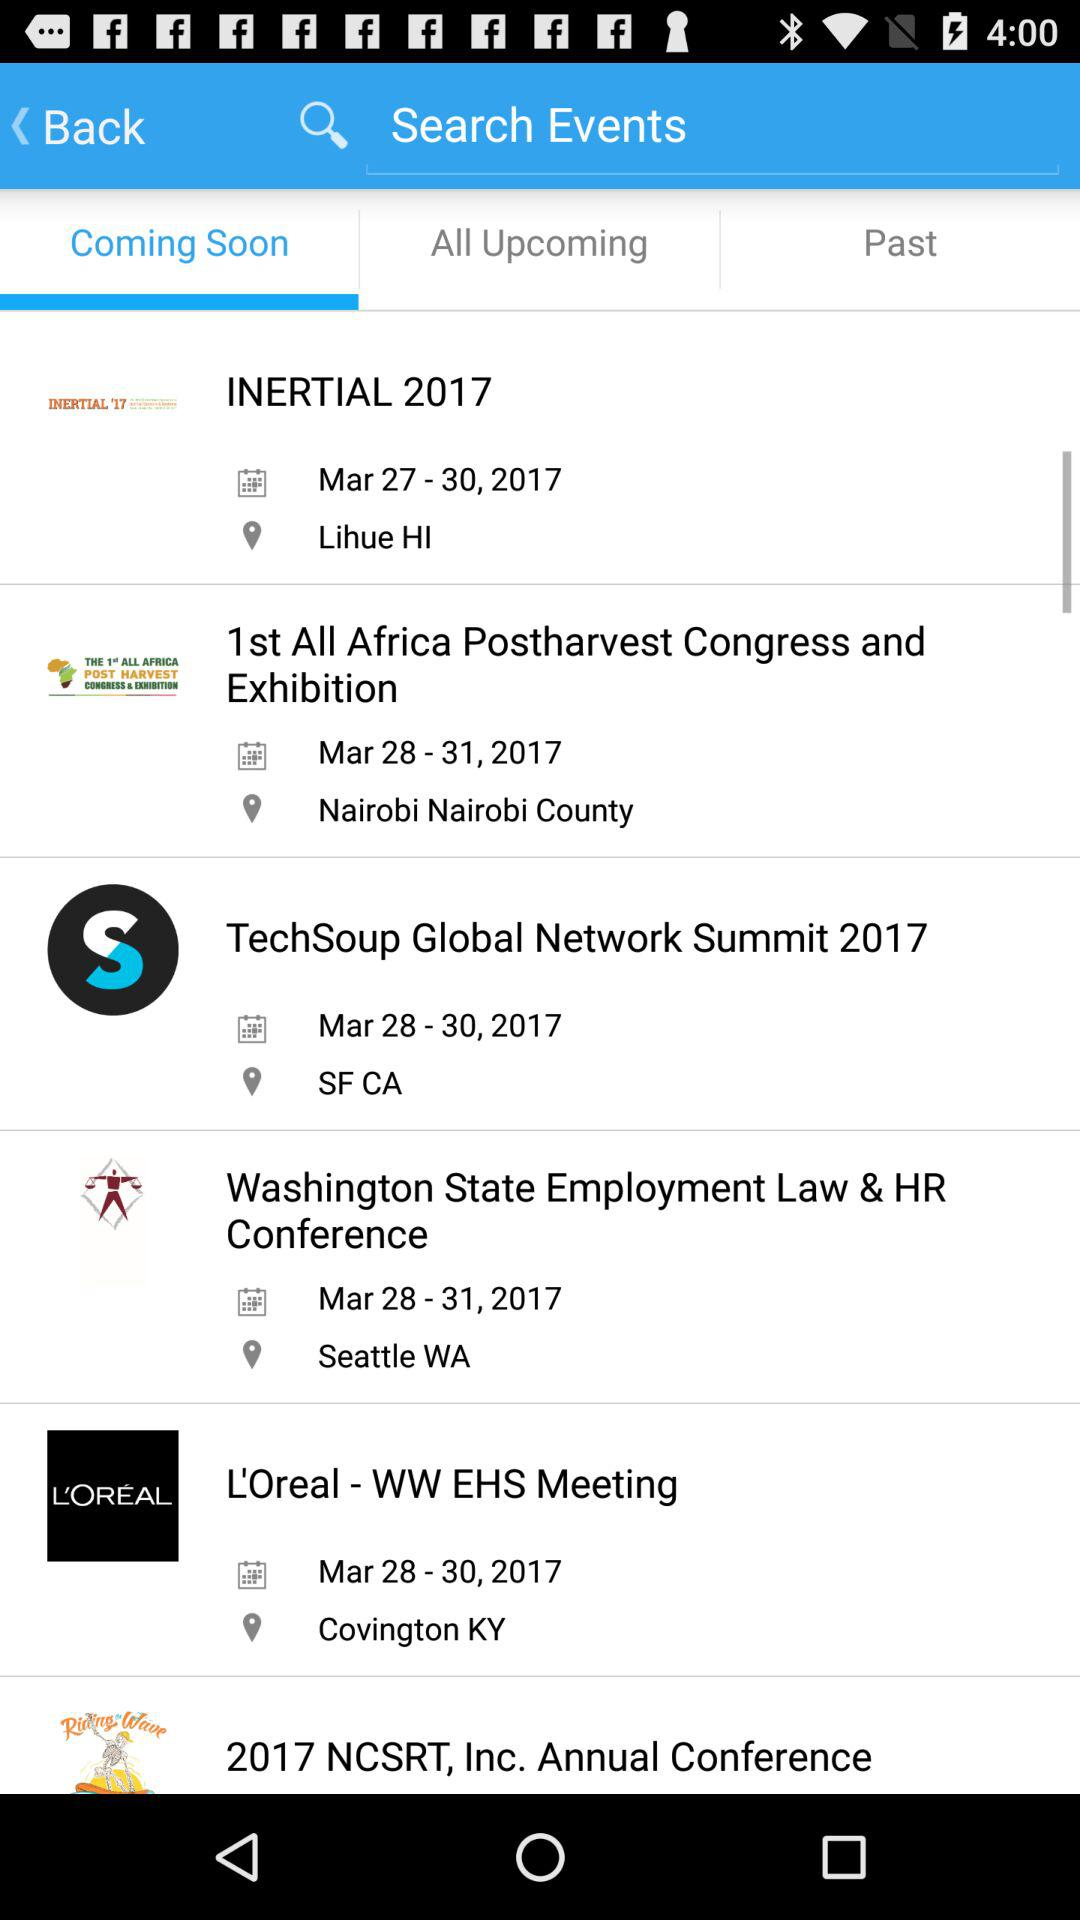What events are coming soon? The events that are coming soon are "INERTIAL 2017", "1st All Africa Postharvest Congress and Exhibition", "TechSoup Global Network Summit 2017", "Washington State Employment Law & HR Conference", "L'Oreal - WW EHS Meeting" and "2017 NCSRT, Inc. Annual Conference". 